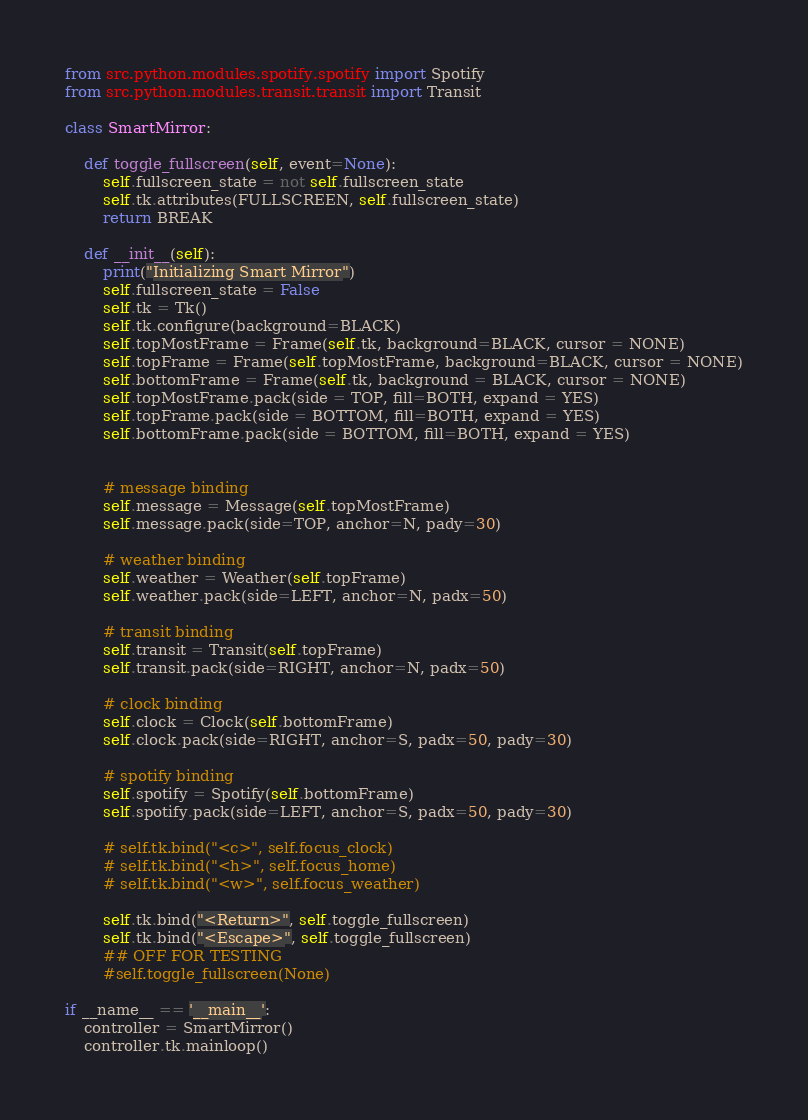Convert code to text. <code><loc_0><loc_0><loc_500><loc_500><_Python_>from src.python.modules.spotify.spotify import Spotify
from src.python.modules.transit.transit import Transit

class SmartMirror:

    def toggle_fullscreen(self, event=None):
        self.fullscreen_state = not self.fullscreen_state
        self.tk.attributes(FULLSCREEN, self.fullscreen_state)
        return BREAK

    def __init__(self):
        print("Initializing Smart Mirror")
        self.fullscreen_state = False
        self.tk = Tk()
        self.tk.configure(background=BLACK)
        self.topMostFrame = Frame(self.tk, background=BLACK, cursor = NONE)
        self.topFrame = Frame(self.topMostFrame, background=BLACK, cursor = NONE)
        self.bottomFrame = Frame(self.tk, background = BLACK, cursor = NONE)
        self.topMostFrame.pack(side = TOP, fill=BOTH, expand = YES)
        self.topFrame.pack(side = BOTTOM, fill=BOTH, expand = YES)
        self.bottomFrame.pack(side = BOTTOM, fill=BOTH, expand = YES)


        # message binding
        self.message = Message(self.topMostFrame)
        self.message.pack(side=TOP, anchor=N, pady=30)

        # weather binding
        self.weather = Weather(self.topFrame)
        self.weather.pack(side=LEFT, anchor=N, padx=50)

        # transit binding
        self.transit = Transit(self.topFrame)
        self.transit.pack(side=RIGHT, anchor=N, padx=50)

        # clock binding
        self.clock = Clock(self.bottomFrame)
        self.clock.pack(side=RIGHT, anchor=S, padx=50, pady=30)

        # spotify binding
        self.spotify = Spotify(self.bottomFrame)
        self.spotify.pack(side=LEFT, anchor=S, padx=50, pady=30)

        # self.tk.bind("<c>", self.focus_clock)
        # self.tk.bind("<h>", self.focus_home)
        # self.tk.bind("<w>", self.focus_weather)

        self.tk.bind("<Return>", self.toggle_fullscreen)
        self.tk.bind("<Escape>", self.toggle_fullscreen)
        ## OFF FOR TESTING
        #self.toggle_fullscreen(None)

if __name__ == '__main__':
    controller = SmartMirror()
    controller.tk.mainloop()</code> 